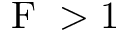<formula> <loc_0><loc_0><loc_500><loc_500>F > 1</formula> 